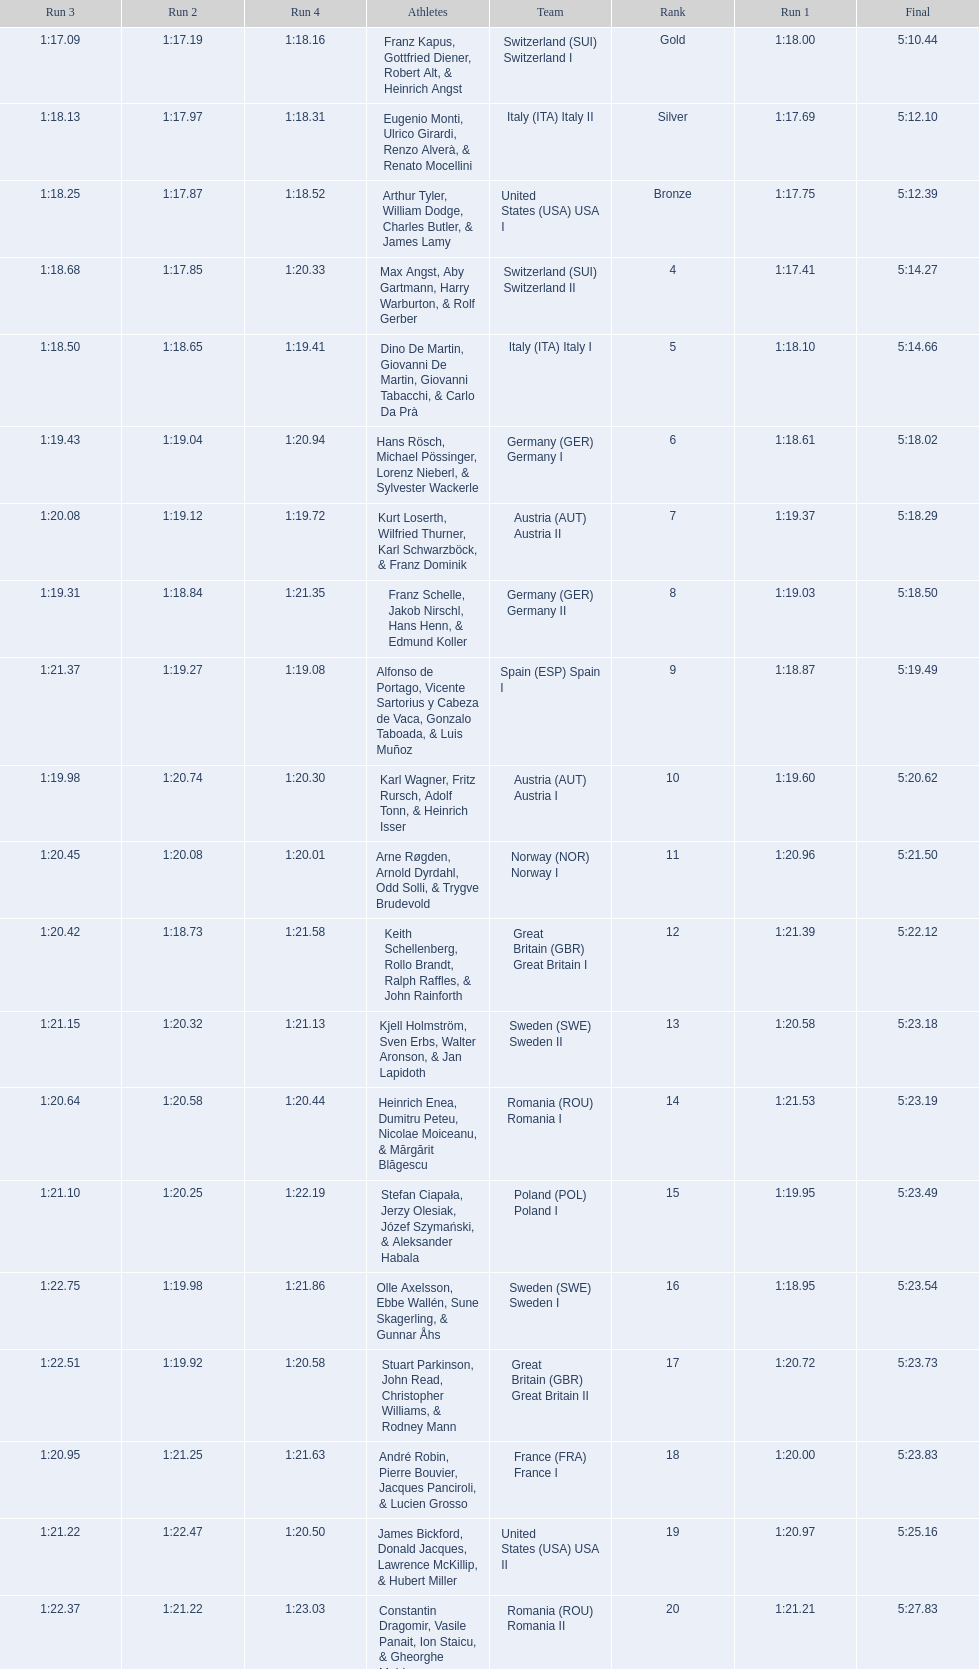What is the total amount of runs? 4. 